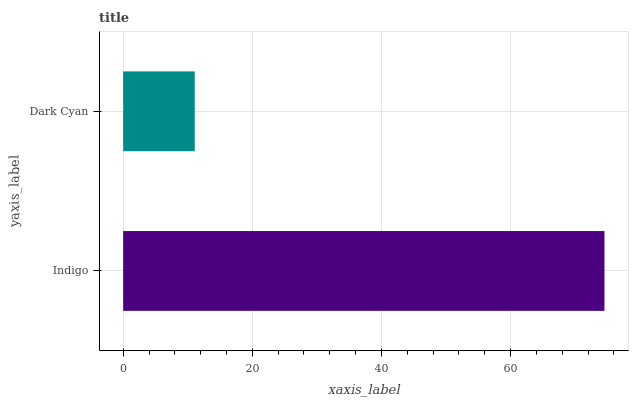Is Dark Cyan the minimum?
Answer yes or no. Yes. Is Indigo the maximum?
Answer yes or no. Yes. Is Dark Cyan the maximum?
Answer yes or no. No. Is Indigo greater than Dark Cyan?
Answer yes or no. Yes. Is Dark Cyan less than Indigo?
Answer yes or no. Yes. Is Dark Cyan greater than Indigo?
Answer yes or no. No. Is Indigo less than Dark Cyan?
Answer yes or no. No. Is Indigo the high median?
Answer yes or no. Yes. Is Dark Cyan the low median?
Answer yes or no. Yes. Is Dark Cyan the high median?
Answer yes or no. No. Is Indigo the low median?
Answer yes or no. No. 